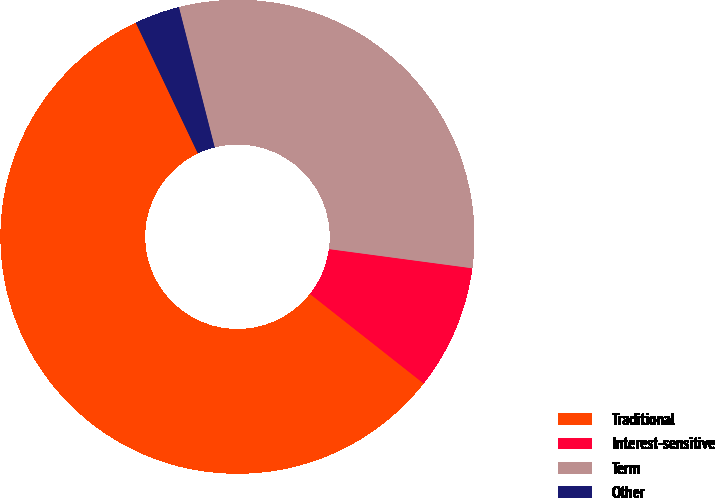Convert chart to OTSL. <chart><loc_0><loc_0><loc_500><loc_500><pie_chart><fcel>Traditional<fcel>Interest-sensitive<fcel>Term<fcel>Other<nl><fcel>57.32%<fcel>8.5%<fcel>31.09%<fcel>3.08%<nl></chart> 